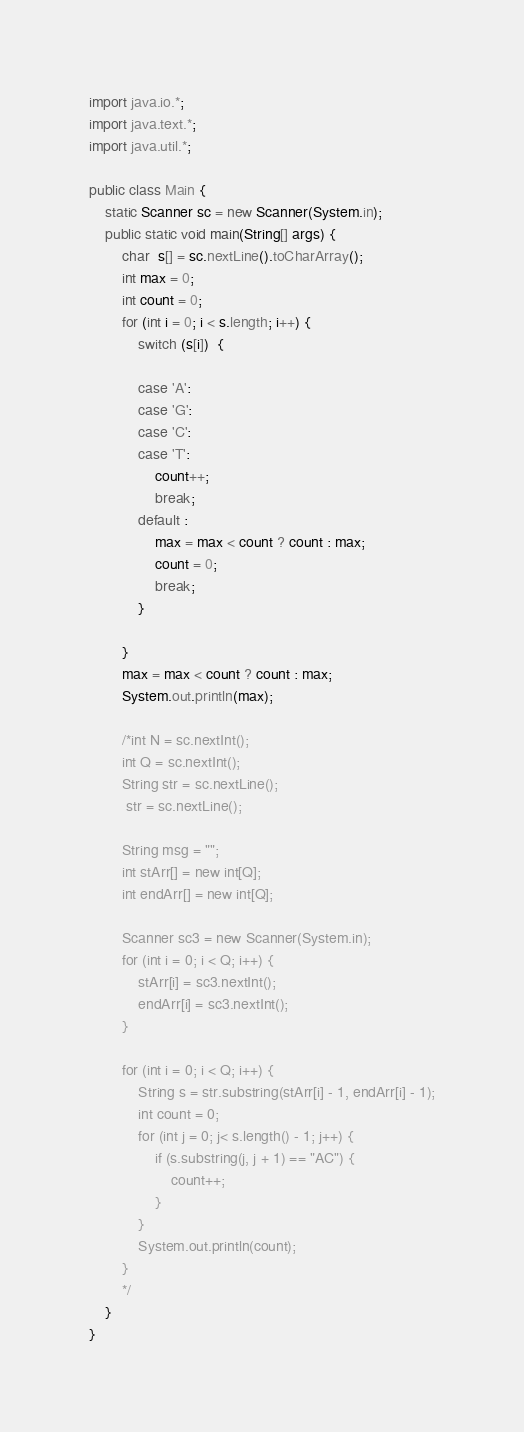<code> <loc_0><loc_0><loc_500><loc_500><_Java_>
import java.io.*;
import java.text.*;
import java.util.*;
 
public class Main {
	static Scanner sc = new Scanner(System.in);
	public static void main(String[] args) {
		char  s[] = sc.nextLine().toCharArray();
		int max = 0;
		int count = 0;
		for (int i = 0; i < s.length; i++) {
			switch (s[i])  {

			case 'A':
			case 'G':
			case 'C':
			case 'T':
				count++;
				break;
			default : 
				max = max < count ? count : max;
				count = 0;
				break;
			}
				
		}
		max = max < count ? count : max;
		System.out.println(max);
		
		/*int N = sc.nextInt();
		int Q = sc.nextInt();
		String str = sc.nextLine();
		 str = sc.nextLine();

		String msg = "";
		int stArr[] = new int[Q];
		int endArr[] = new int[Q];

		Scanner sc3 = new Scanner(System.in);
		for (int i = 0; i < Q; i++) {
			stArr[i] = sc3.nextInt();
			endArr[i] = sc3.nextInt();
		}
		
		for (int i = 0; i < Q; i++) {
			String s = str.substring(stArr[i] - 1, endArr[i] - 1);
			int count = 0;
			for (int j = 0; j< s.length() - 1; j++) {
				if (s.substring(j, j + 1) == "AC") {
					count++;
				}
			}
			System.out.println(count);
		}
		*/
	}
}</code> 